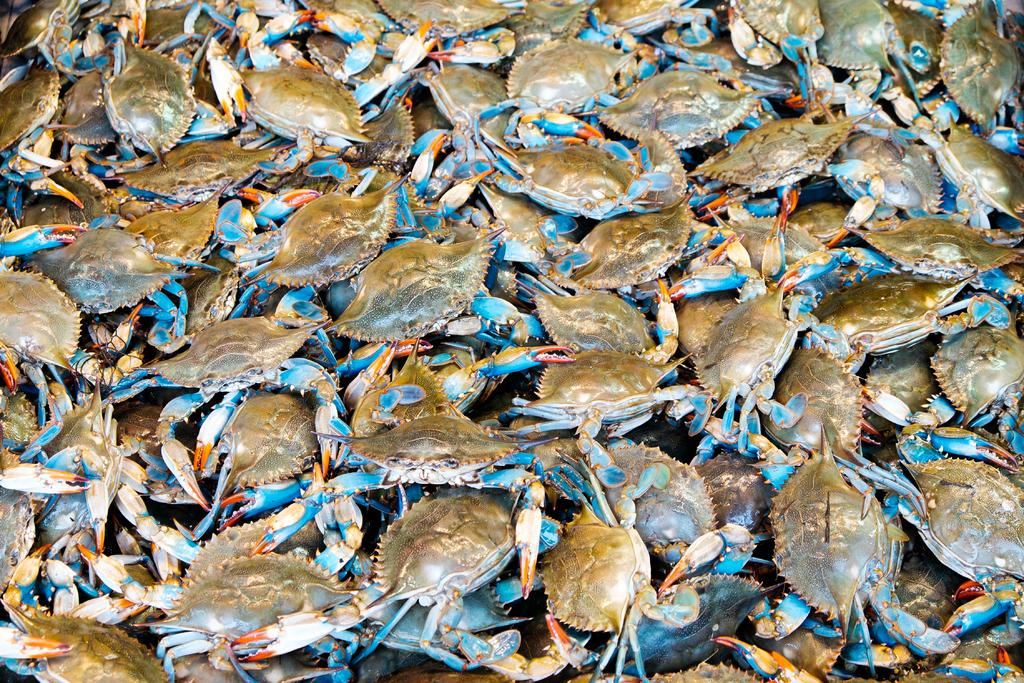What type of animals are present in the image? There are crabs in the image. What type of crack is visible on the brick in the image? There is no brick or crack present in the image; it only features crabs. What is the weather like in the image? The provided facts do not mention the weather, so it cannot be determined from the image. 